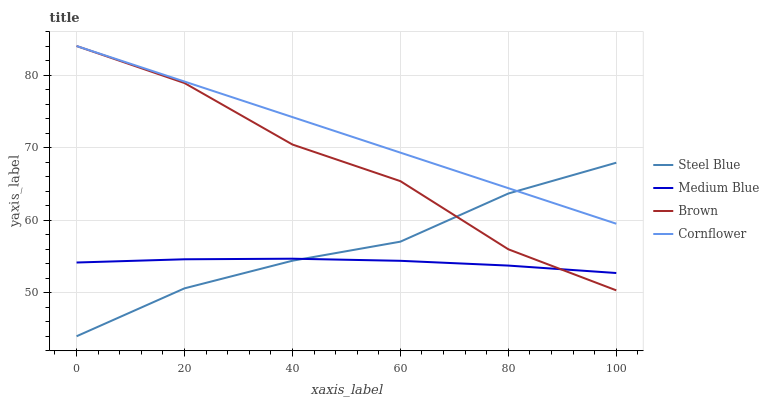Does Medium Blue have the minimum area under the curve?
Answer yes or no. Yes. Does Cornflower have the maximum area under the curve?
Answer yes or no. Yes. Does Steel Blue have the minimum area under the curve?
Answer yes or no. No. Does Steel Blue have the maximum area under the curve?
Answer yes or no. No. Is Cornflower the smoothest?
Answer yes or no. Yes. Is Brown the roughest?
Answer yes or no. Yes. Is Medium Blue the smoothest?
Answer yes or no. No. Is Medium Blue the roughest?
Answer yes or no. No. Does Steel Blue have the lowest value?
Answer yes or no. Yes. Does Medium Blue have the lowest value?
Answer yes or no. No. Does Cornflower have the highest value?
Answer yes or no. Yes. Does Steel Blue have the highest value?
Answer yes or no. No. Is Medium Blue less than Cornflower?
Answer yes or no. Yes. Is Cornflower greater than Medium Blue?
Answer yes or no. Yes. Does Steel Blue intersect Cornflower?
Answer yes or no. Yes. Is Steel Blue less than Cornflower?
Answer yes or no. No. Is Steel Blue greater than Cornflower?
Answer yes or no. No. Does Medium Blue intersect Cornflower?
Answer yes or no. No. 